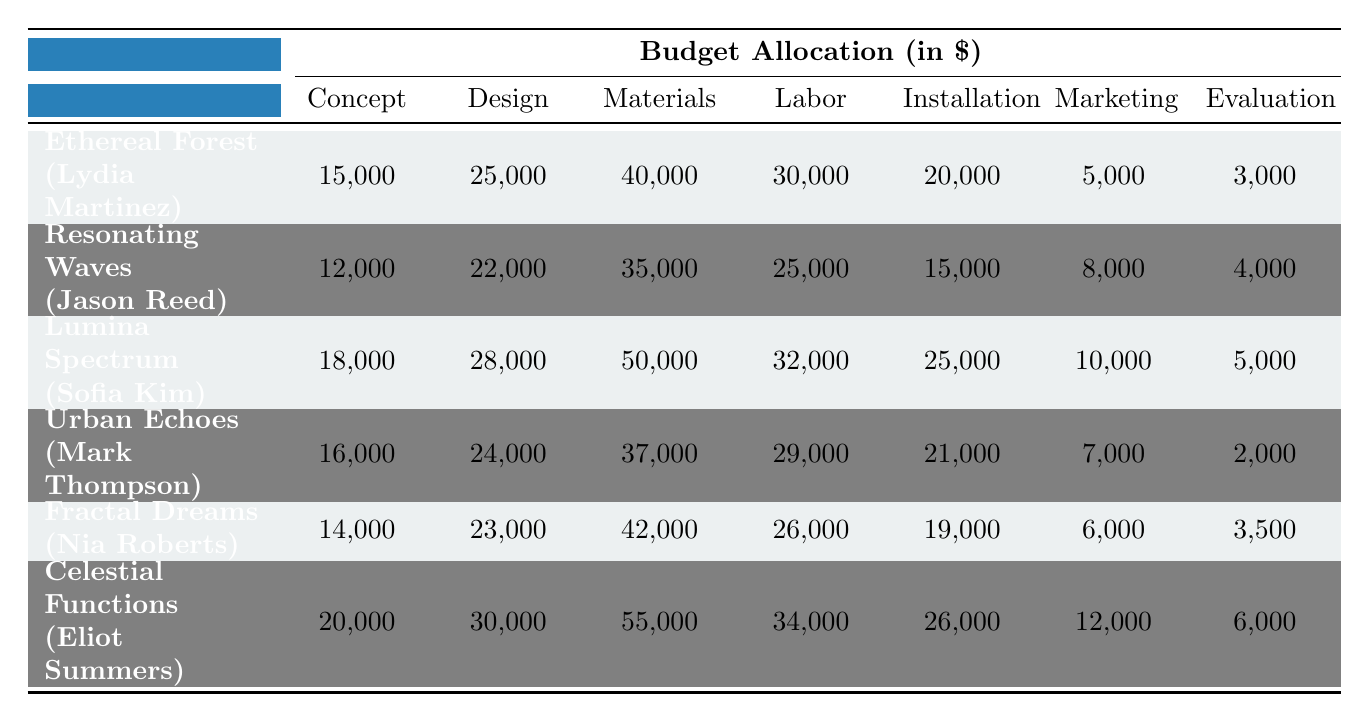What is the budget for the materials phase of the "Lumina Spectrum" project? The materials phase budget for "Lumina Spectrum" is directly listed in the table as 50,000.
Answer: 50,000 Which project received the highest budget allocation for the labor phase? By examining the labor phase budgets, "Celestial Functions" has the highest allocation of 34,000 compared to others.
Answer: Celestial Functions What is the total budget allocated for the "Ethereal Forest" project across all phases? Summing the budgets for all phases of "Ethereal Forest": 15,000 + 25,000 + 40,000 + 30,000 + 20,000 + 5,000 + 3,000 = 138,000.
Answer: 138,000 Is the evaluation phase budget for "Fractal Dreams" greater than that of "Urban Echoes"? The evaluation phase budgets are 3,500 for "Fractal Dreams" and 2,000 for "Urban Echoes." Since 3,500 > 2,000, the statement is true.
Answer: Yes What is the average budget for the concept phase across all projects? Adding the concept phase budgets: 15,000 + 12,000 + 18,000 + 16,000 + 14,000 + 20,000 = 95,000. There are 6 projects, so the average is 95,000 / 6 = 15,833.33.
Answer: 15,833.33 What is the difference between the highest and lowest budget for the installation phase? The highest budget for the installation phase is 26,000 (Celestial Functions) and the lowest is 15,000 (Resonating Waves). The difference is 26,000 - 15,000 = 11,000.
Answer: 11,000 Which artist has the lowest total budget across all phases, and what is that total? Summing the phases for each artist reveals that "Resonating Waves" (Jason Reed) has the lowest total: 12,000 + 22,000 + 35,000 + 25,000 + 15,000 + 8,000 + 4,000 = 121,000.
Answer: Jason Reed, 121,000 If we combine the marketing budgets of all projects, what would that total be? Summing all marketing budgets: 5,000 + 8,000 + 10,000 + 7,000 + 6,000 + 12,000 = 48,000.
Answer: 48,000 Which project has a higher total budget, "Celestial Functions" or "Lumina Spectrum"? The total budget for "Celestial Functions" is 200,000 (adding all phases) and for "Lumina Spectrum" is 193,000. Since 200,000 > 193,000, "Celestial Functions" has the higher budget.
Answer: Celestial Functions Is the sum of the marketing budgets for "Ethereal Forest" and "Fractal Dreams" less than the marketing budget for "Lumina Spectrum"? The marketing budgets are 5,000 (Ethereal Forest) + 6,000 (Fractal Dreams) = 11,000. Lumina Spectrum has a marketing budget of 10,000. Since 11,000 > 10,000, the statement is false.
Answer: No 